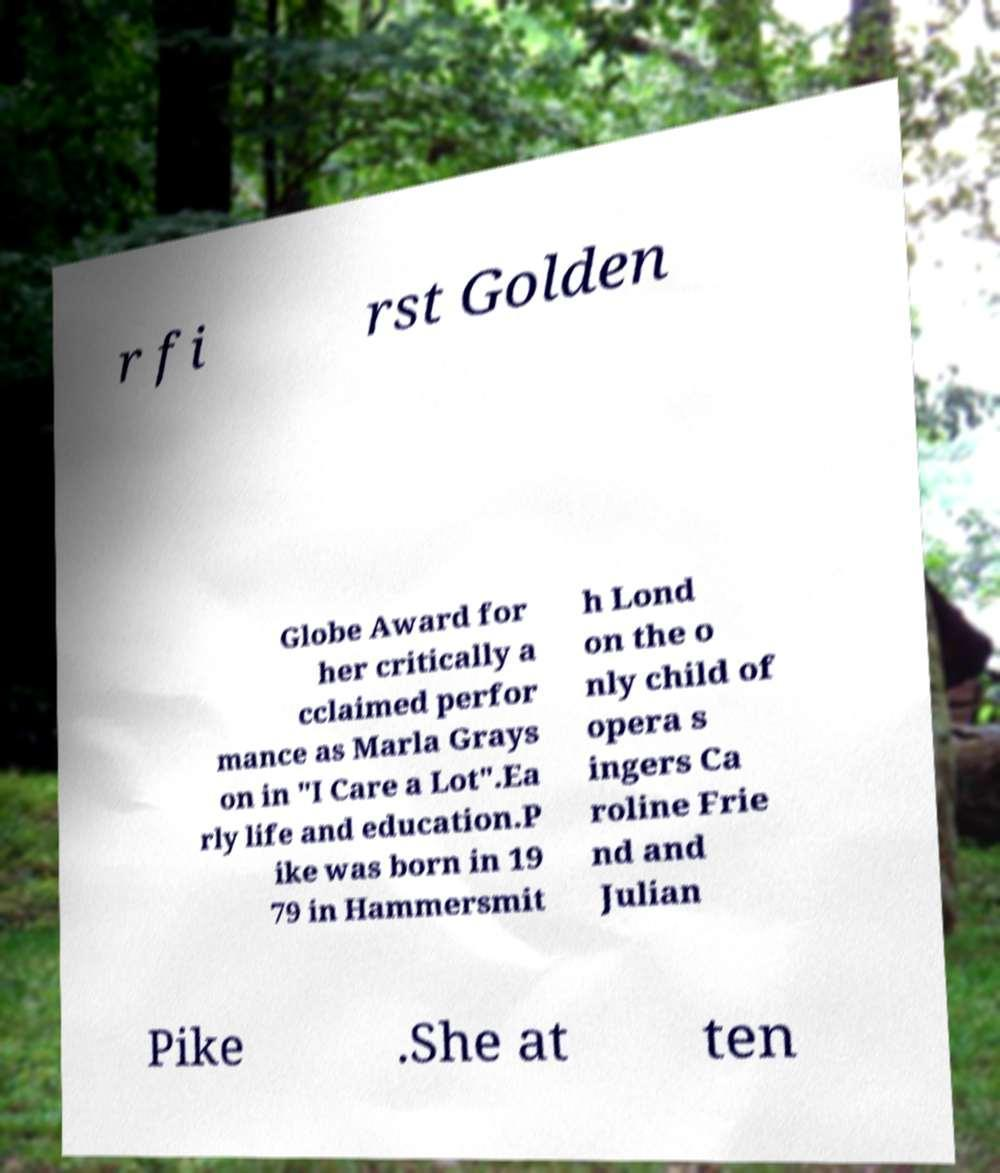Please read and relay the text visible in this image. What does it say? r fi rst Golden Globe Award for her critically a cclaimed perfor mance as Marla Grays on in "I Care a Lot".Ea rly life and education.P ike was born in 19 79 in Hammersmit h Lond on the o nly child of opera s ingers Ca roline Frie nd and Julian Pike .She at ten 